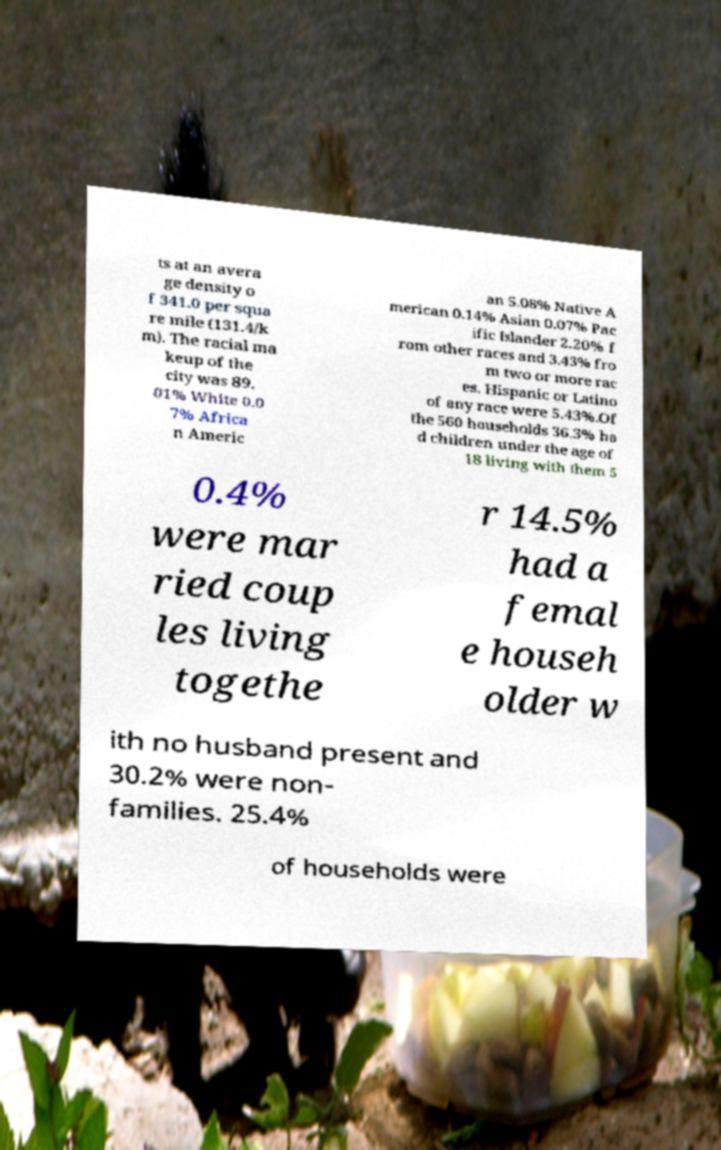Please read and relay the text visible in this image. What does it say? ts at an avera ge density o f 341.0 per squa re mile (131.4/k m). The racial ma keup of the city was 89. 01% White 0.0 7% Africa n Americ an 5.08% Native A merican 0.14% Asian 0.07% Pac ific Islander 2.20% f rom other races and 3.43% fro m two or more rac es. Hispanic or Latino of any race were 5.43%.Of the 560 households 36.3% ha d children under the age of 18 living with them 5 0.4% were mar ried coup les living togethe r 14.5% had a femal e househ older w ith no husband present and 30.2% were non- families. 25.4% of households were 